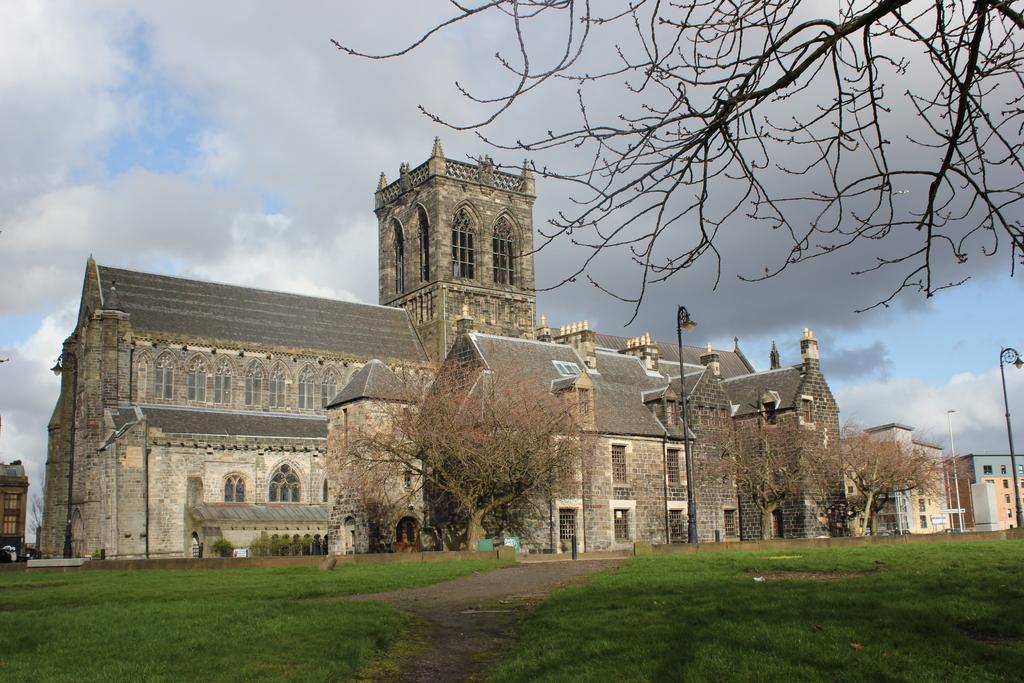In one or two sentences, can you explain what this image depicts? In the picture I can see buildings, trees, street lights, the grass and some other objects on the ground. In the background I can see the sky. 